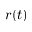<formula> <loc_0><loc_0><loc_500><loc_500>r ( t )</formula> 